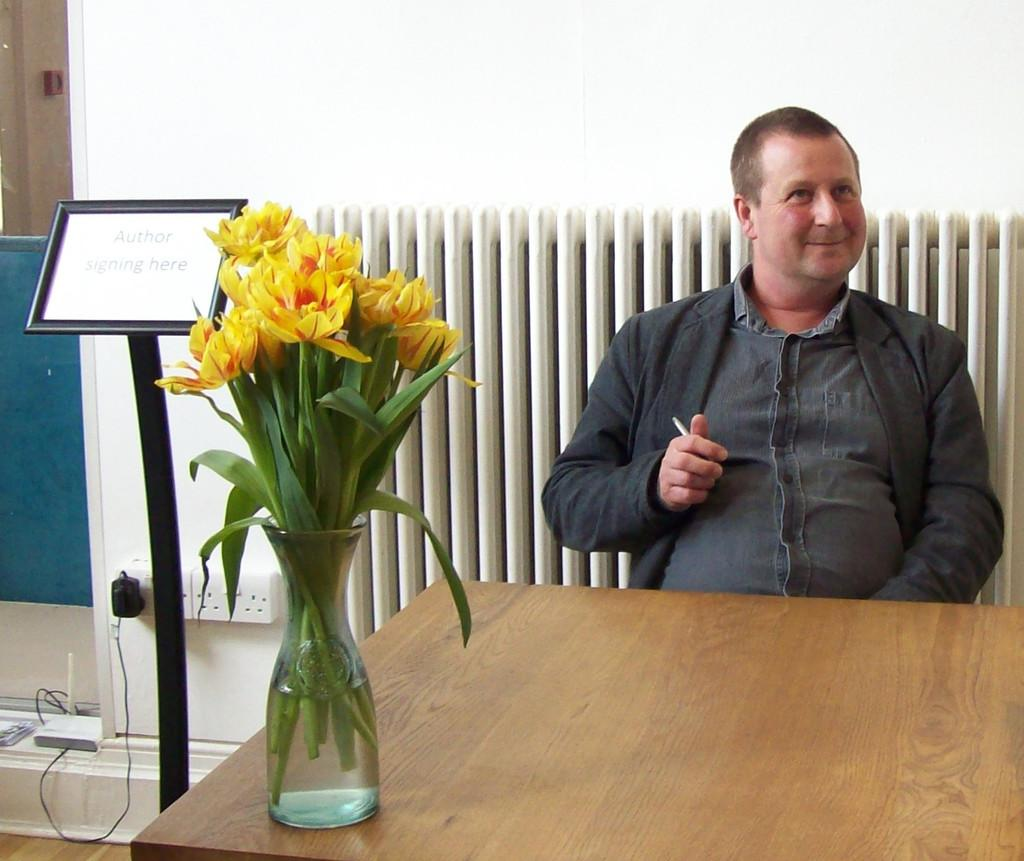Who is present in the image? There is a man in the image. What object can be seen on the table? There is a flower pot on the table. What is the purpose of the board in the image? The purpose of the board in the image is not specified, but it could be used for writing, displaying information, or as a decorative element. What type of structure is visible in the image? There is a wall visible in the image. Where is the lunchroom located in the image? There is no mention of a lunchroom in the image, so its location cannot be determined. 